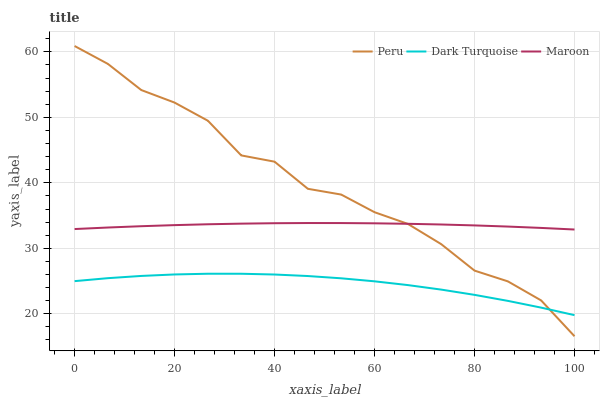Does Dark Turquoise have the minimum area under the curve?
Answer yes or no. Yes. Does Peru have the maximum area under the curve?
Answer yes or no. Yes. Does Maroon have the minimum area under the curve?
Answer yes or no. No. Does Maroon have the maximum area under the curve?
Answer yes or no. No. Is Maroon the smoothest?
Answer yes or no. Yes. Is Peru the roughest?
Answer yes or no. Yes. Is Peru the smoothest?
Answer yes or no. No. Is Maroon the roughest?
Answer yes or no. No. Does Maroon have the lowest value?
Answer yes or no. No. Does Peru have the highest value?
Answer yes or no. Yes. Does Maroon have the highest value?
Answer yes or no. No. Is Dark Turquoise less than Maroon?
Answer yes or no. Yes. Is Maroon greater than Dark Turquoise?
Answer yes or no. Yes. Does Dark Turquoise intersect Maroon?
Answer yes or no. No. 